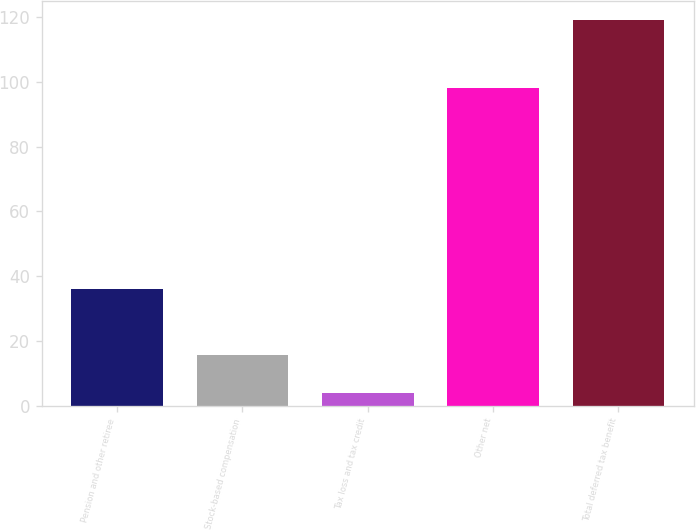Convert chart to OTSL. <chart><loc_0><loc_0><loc_500><loc_500><bar_chart><fcel>Pension and other retiree<fcel>Stock-based compensation<fcel>Tax loss and tax credit<fcel>Other net<fcel>Total deferred tax benefit<nl><fcel>36<fcel>15.5<fcel>4<fcel>98<fcel>119<nl></chart> 